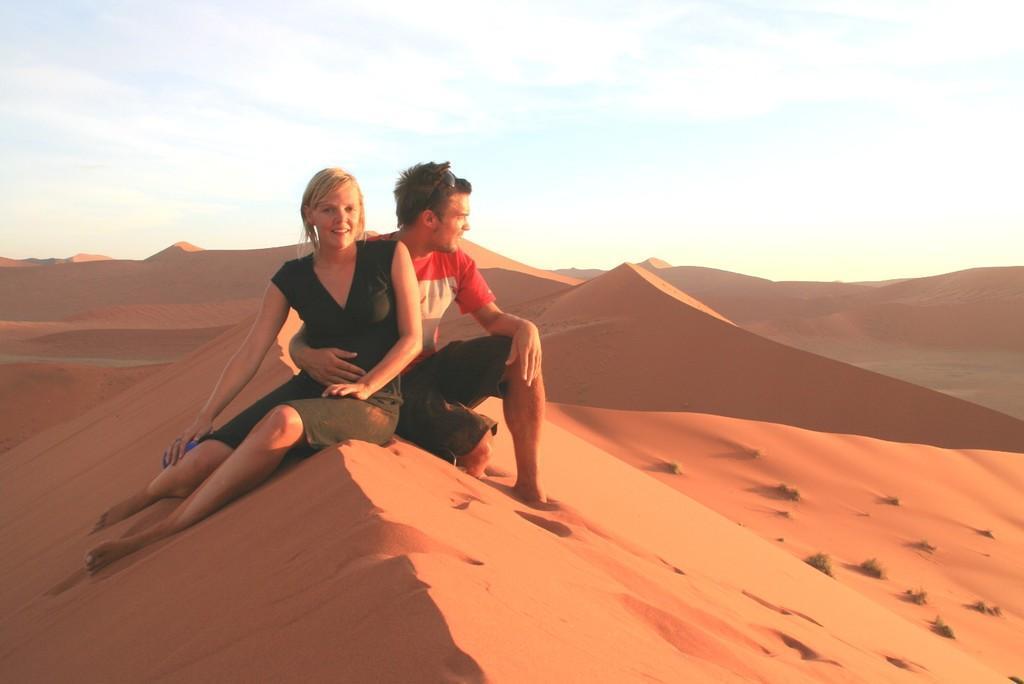In one or two sentences, can you explain what this image depicts? In this image there are two persons in the foreground. There is sand at the bottom. There are small plants in the right corner. There are mountains in the background. And there is a sky at the top. 